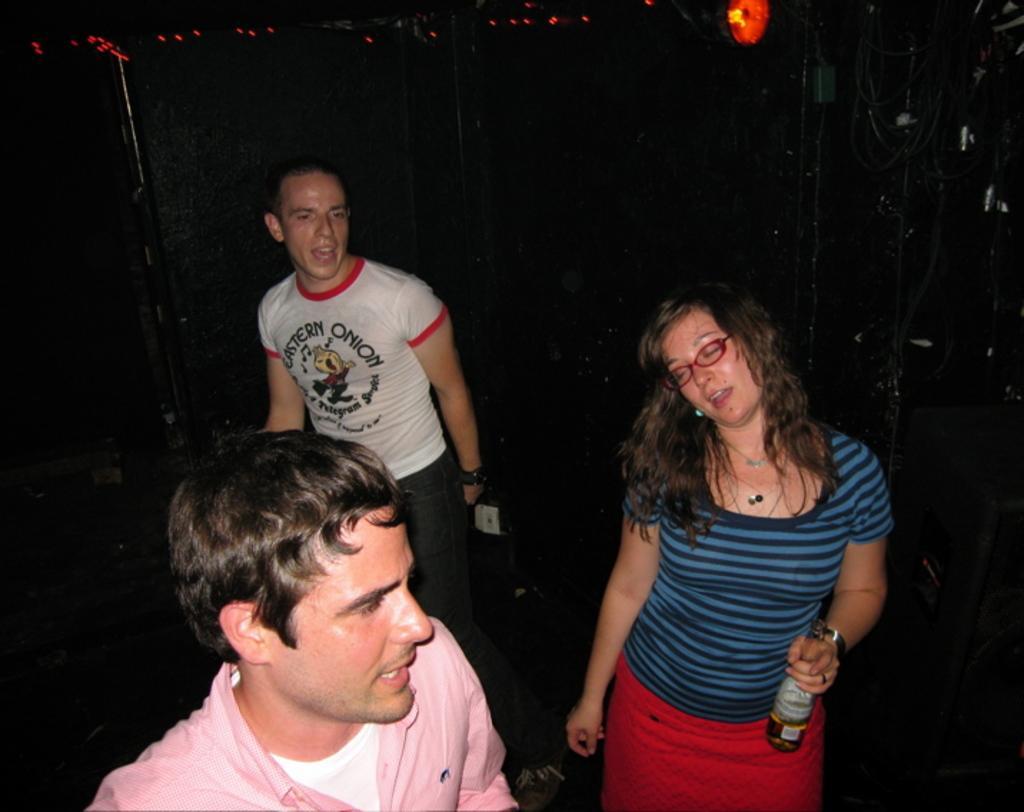In one or two sentences, can you explain what this image depicts? In this image I can see three persons standing. The person in front wearing pink and white shirt, the person at right wearing blue shirt, red skirt holding a bottle and I can see dark background. 